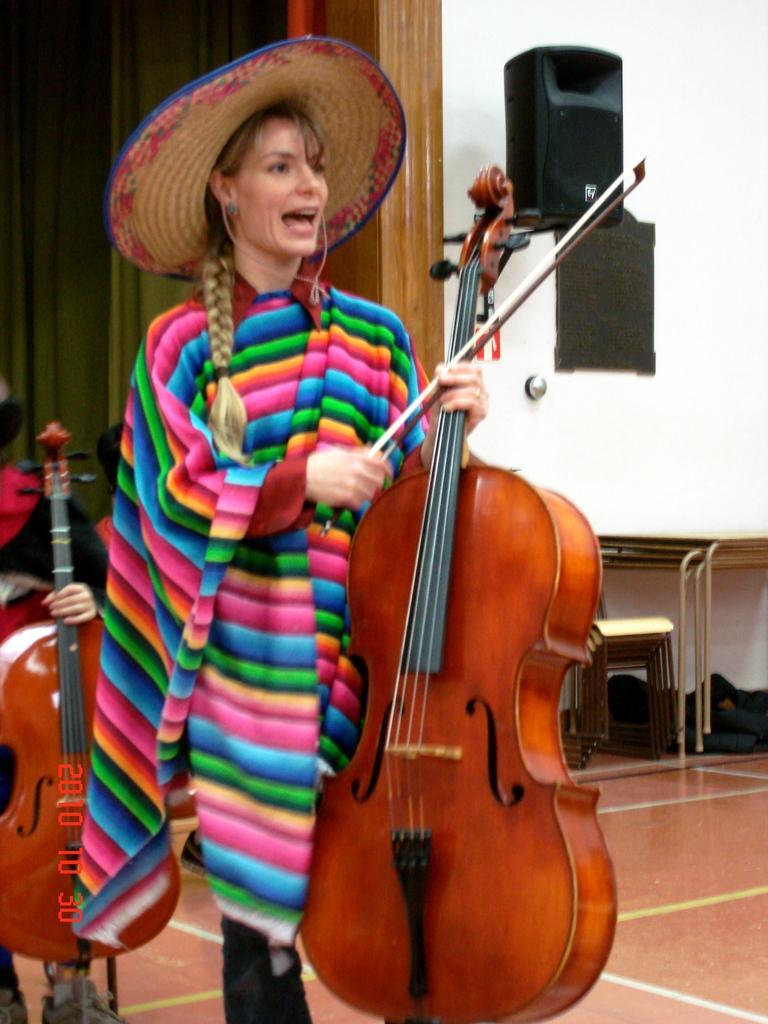How would you summarize this image in a sentence or two? In this picture we can see a woman wearing colorful dress and holding big wooden violin in her hand and wearing cowboy cap. Behind we can see a white wall, speaker and wooden panel door. Behind the girl we can see man sitting and playing violin. 